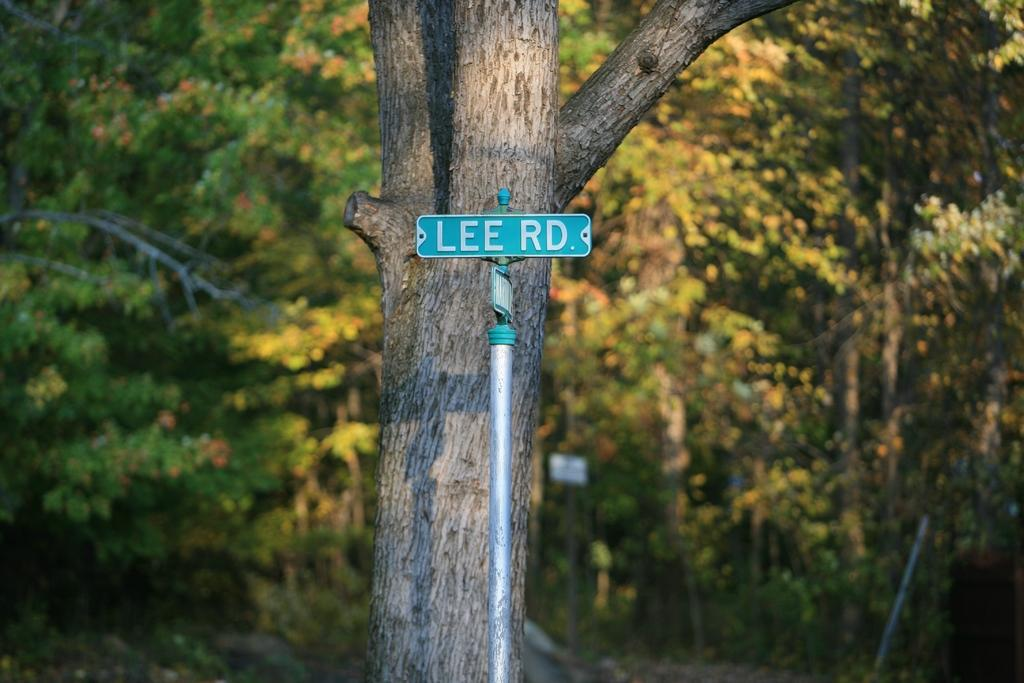What is the main object in the image? There is a rod with a board attached to it in the image. What is written or depicted on the board? There is text on the board. What can be seen behind the rod and board? There is a tree behind the rod and board. What else is visible in the background of the image? There are trees visible in the background of the image. How many grapes are hanging from the tree in the image? There are no grapes visible in the image; the tree behind the rod and board does not have any grapes. What type of vein is present in the image? There is no reference to a vein in the image; the focus is on the rod, board, and trees. 